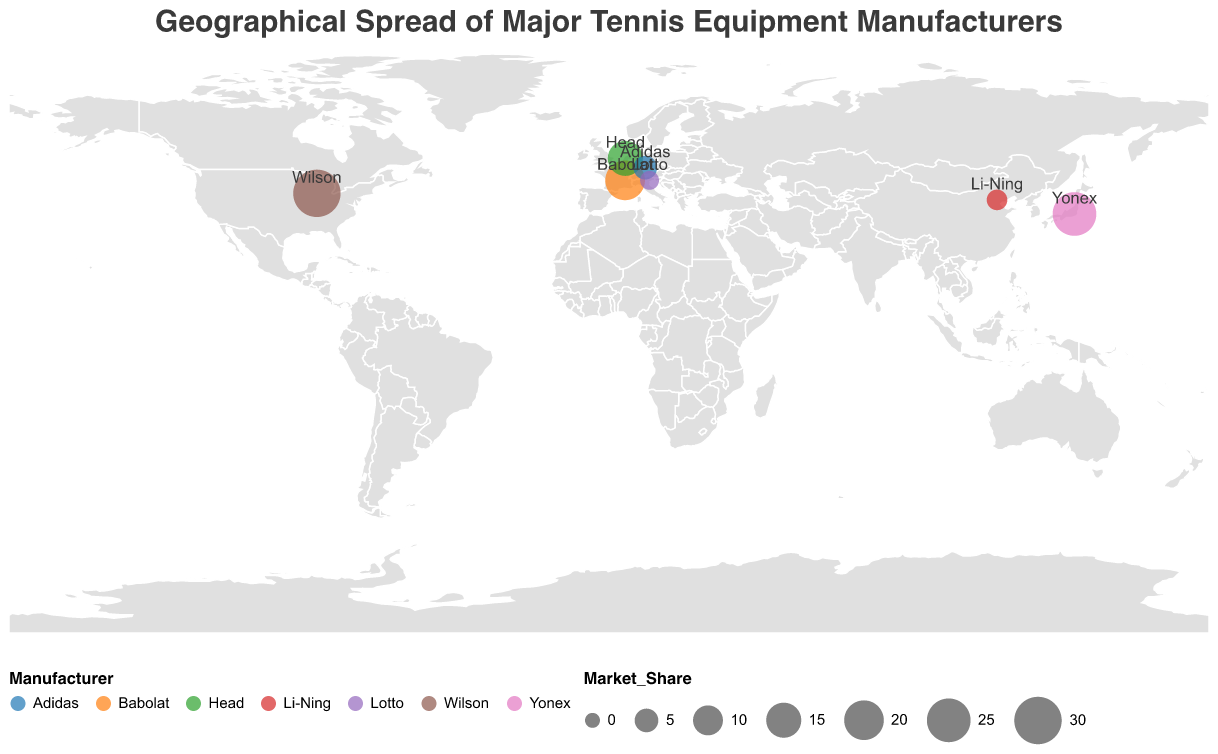What is the title of the figure? The title of the figure is displayed prominently at the top of the visual and can be read directly from there.
Answer: Geographical Spread of Major Tennis Equipment Manufacturers Which manufacturer has the largest market share and where is it headquartered? Look for the circle with the largest size and its corresponding label, then read the associated data tooltip or text label for the market share and headquarters location.
Answer: Wilson, Chicago How many manufacturers are represented in the plot? Count the number of distinct data points or text labels on the map representing different manufacturers. In this case, each circle represents a different manufacturer.
Answer: 7 What is the total combined market share of manufacturers headquartered in Europe? Identify the manufacturers headquartered in European countries (France, Austria, Germany, Italy), then sum their market shares: Babolat (20%), Head (15%), Adidas (5%), and Lotto (2%).
Answer: 42% Which country is home to the manufacturer with the smallest market share and what is the share percentage? Look for the smallest circle and its corresponding label, then read the associated tooltip or text label for the market share and country.
Answer: Italy, 2% How does Yonex's market share compare to Head's market share? Compare the sizes of circles or read the data tooltips associated with Yonex (Japan) and Head (Austria) to determine their respective market shares.
Answer: Yonex's market share (25%) is greater than Head's market share (15%) Which region has the most diverse range of market shares among manufacturers, and what are the shares? Assess the map for regions and look at the market shares of manufacturers within each region. Europe is the region to focus on, containing France, Austria, Germany, and Italy with market shares of 20%, 15%, 5%, and 2%, respectively.
Answer: Europe, with shares of 20%, 15%, 5%, and 2% What is the average market share of all the manufacturers shown in the plot? Sum the market shares of all manufacturers and then divide by the number of manufacturers: (30 + 25 + 20 + 15 + 5 + 3 + 2) / 7.
Answer: 14.29% What is the second largest market share represented in the plot, and which manufacturer does it belong to? Identify the circle sizes in descending order of market shares, then note the second largest one and its associated manufacturer label.
Answer: 25%, Yonex Of the countries listed, which one has the manufacturer with the third largest market share and what is the market share percentage? Order the manufacturers by market share and identify the third largest market share, then note the associated country.
Answer: France, 20% 